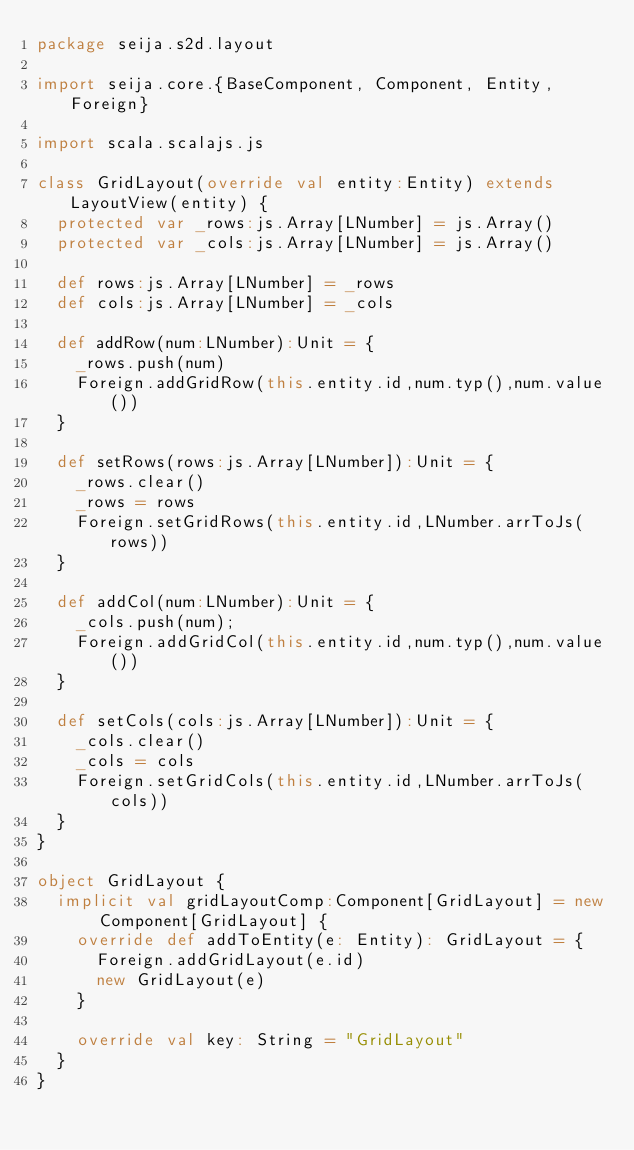Convert code to text. <code><loc_0><loc_0><loc_500><loc_500><_Scala_>package seija.s2d.layout

import seija.core.{BaseComponent, Component, Entity, Foreign}

import scala.scalajs.js

class GridLayout(override val entity:Entity) extends LayoutView(entity) {
  protected var _rows:js.Array[LNumber] = js.Array()
  protected var _cols:js.Array[LNumber] = js.Array()

  def rows:js.Array[LNumber] = _rows
  def cols:js.Array[LNumber] = _cols

  def addRow(num:LNumber):Unit = {
    _rows.push(num)
    Foreign.addGridRow(this.entity.id,num.typ(),num.value())
  }

  def setRows(rows:js.Array[LNumber]):Unit = {
    _rows.clear()
    _rows = rows
    Foreign.setGridRows(this.entity.id,LNumber.arrToJs(rows))
  }

  def addCol(num:LNumber):Unit = {
    _cols.push(num);
    Foreign.addGridCol(this.entity.id,num.typ(),num.value())
  }

  def setCols(cols:js.Array[LNumber]):Unit = {
    _cols.clear()
    _cols = cols
    Foreign.setGridCols(this.entity.id,LNumber.arrToJs(cols))
  }
}

object GridLayout {
  implicit val gridLayoutComp:Component[GridLayout] = new Component[GridLayout] {
    override def addToEntity(e: Entity): GridLayout = {
      Foreign.addGridLayout(e.id)
      new GridLayout(e)
    }

    override val key: String = "GridLayout"
  }
}
</code> 